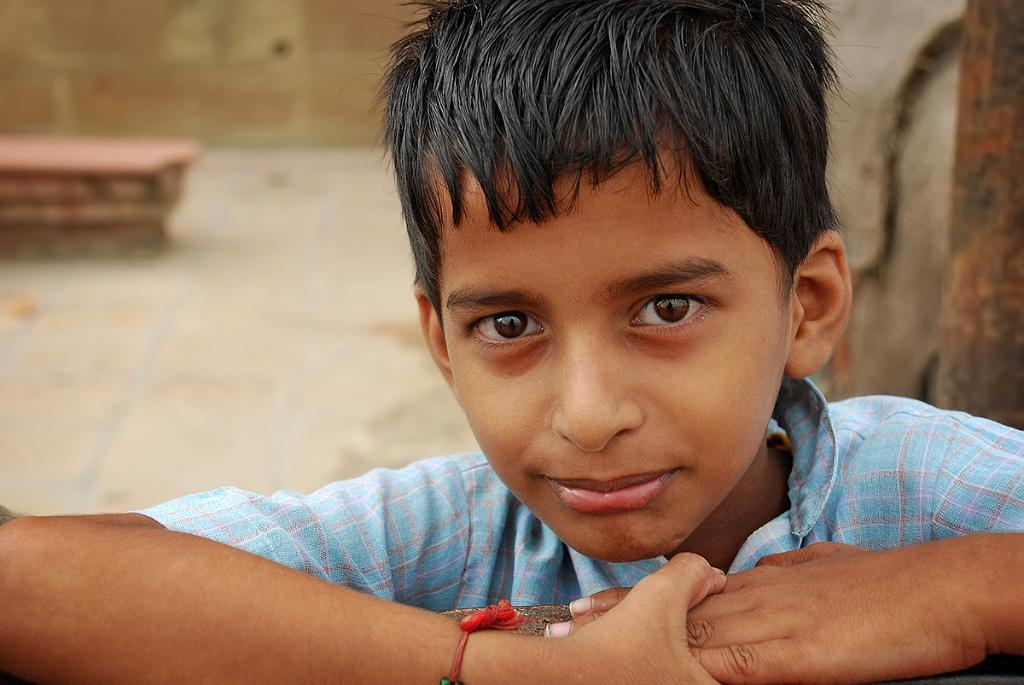Who is the main subject in the picture? There is a boy in the picture. What is the boy wearing? The boy is wearing a blue shirt. Where is the boy located in relation to the wall? The boy is standing near a wall. What can be seen in the background of the picture? There is a bench and a building in the background of the picture. What is the boy doing to express his anger in the picture? There is no indication of anger in the picture; the boy is simply standing near a wall. How does the boy's stomach affect his ability to perform the action in the picture? There is no action being performed by the boy in the picture, and therefore his stomach does not affect any action. 